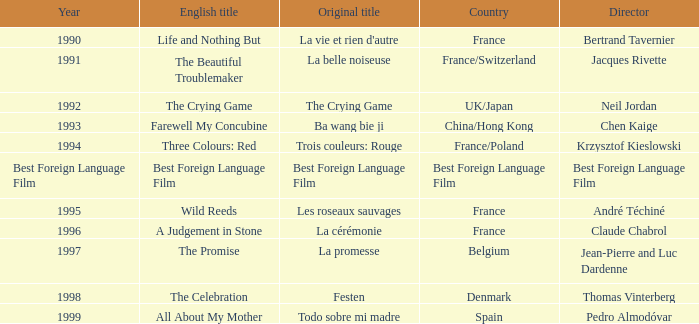For thomas vinterberg, what country is associated with his directorial work? Denmark. 